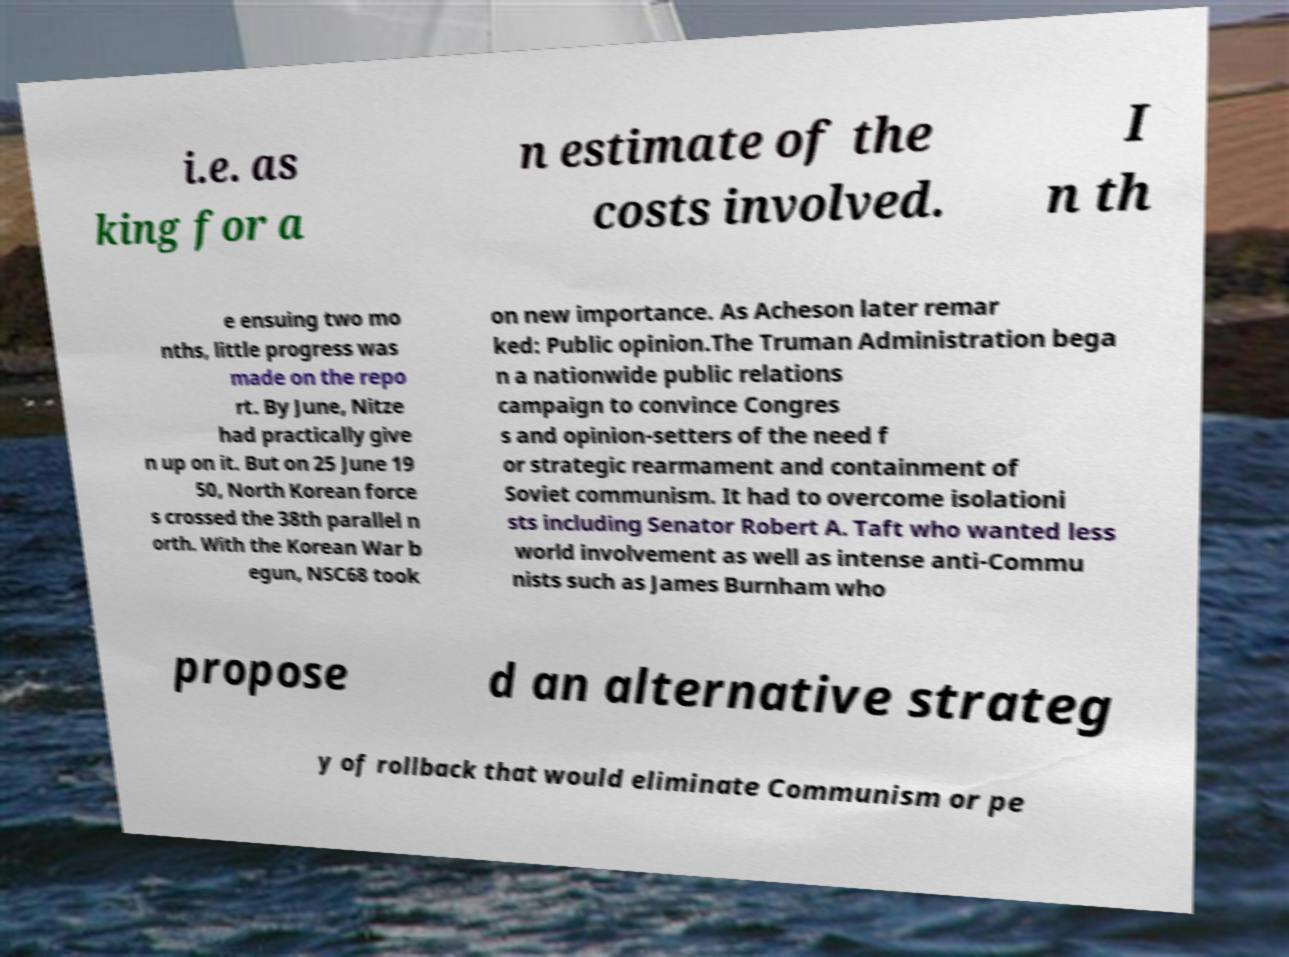Can you read and provide the text displayed in the image?This photo seems to have some interesting text. Can you extract and type it out for me? i.e. as king for a n estimate of the costs involved. I n th e ensuing two mo nths, little progress was made on the repo rt. By June, Nitze had practically give n up on it. But on 25 June 19 50, North Korean force s crossed the 38th parallel n orth. With the Korean War b egun, NSC68 took on new importance. As Acheson later remar ked: Public opinion.The Truman Administration bega n a nationwide public relations campaign to convince Congres s and opinion-setters of the need f or strategic rearmament and containment of Soviet communism. It had to overcome isolationi sts including Senator Robert A. Taft who wanted less world involvement as well as intense anti-Commu nists such as James Burnham who propose d an alternative strateg y of rollback that would eliminate Communism or pe 